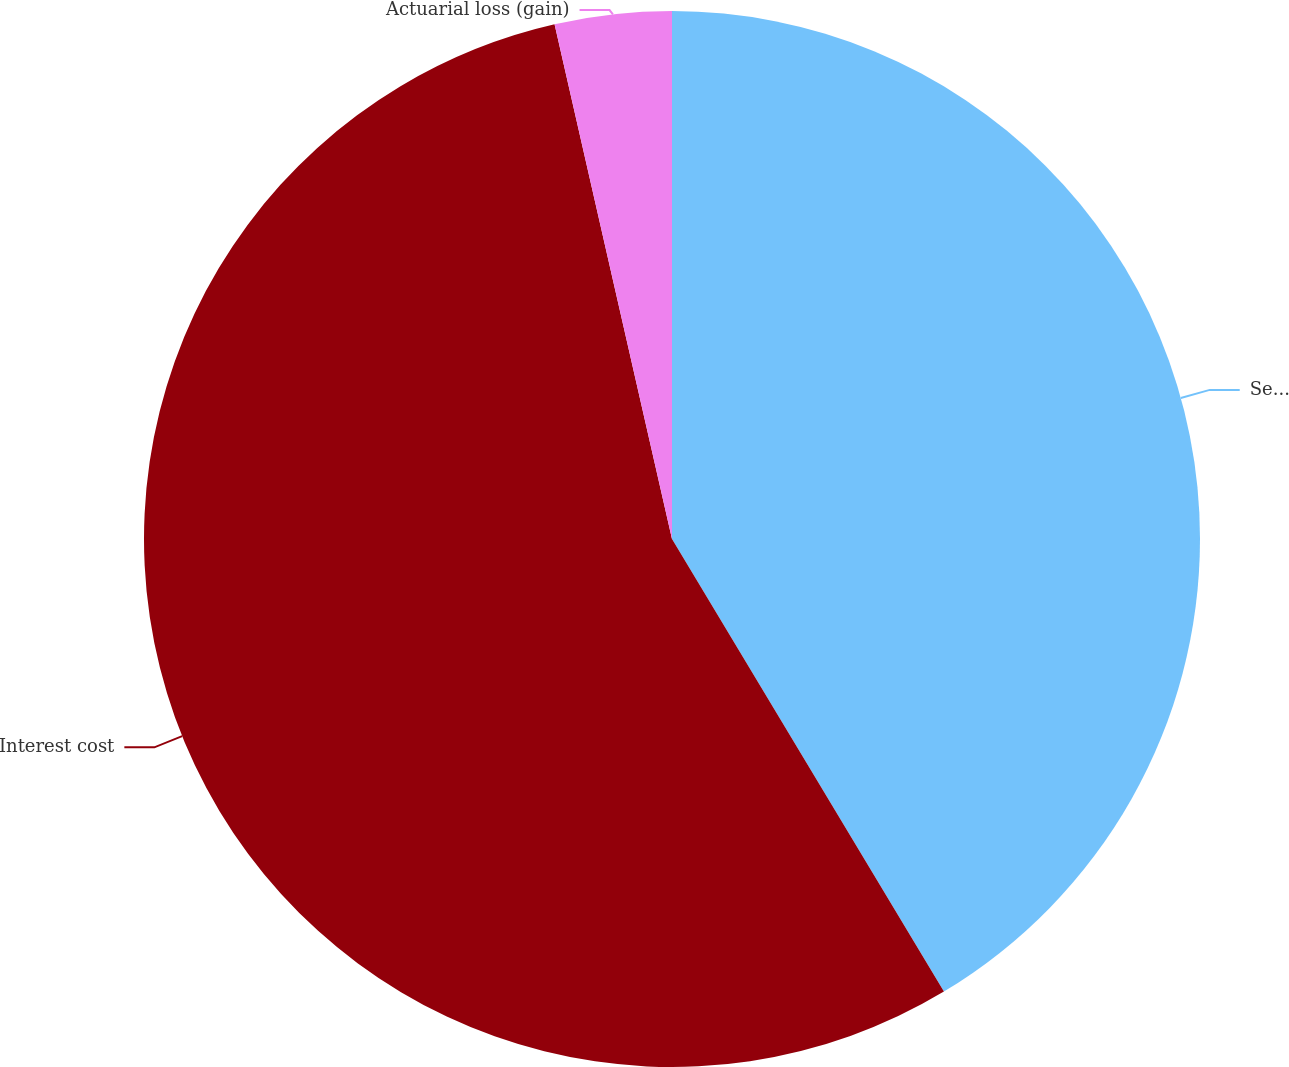Convert chart. <chart><loc_0><loc_0><loc_500><loc_500><pie_chart><fcel>Service cost net<fcel>Interest cost<fcel>Actuarial loss (gain)<nl><fcel>41.39%<fcel>55.04%<fcel>3.57%<nl></chart> 